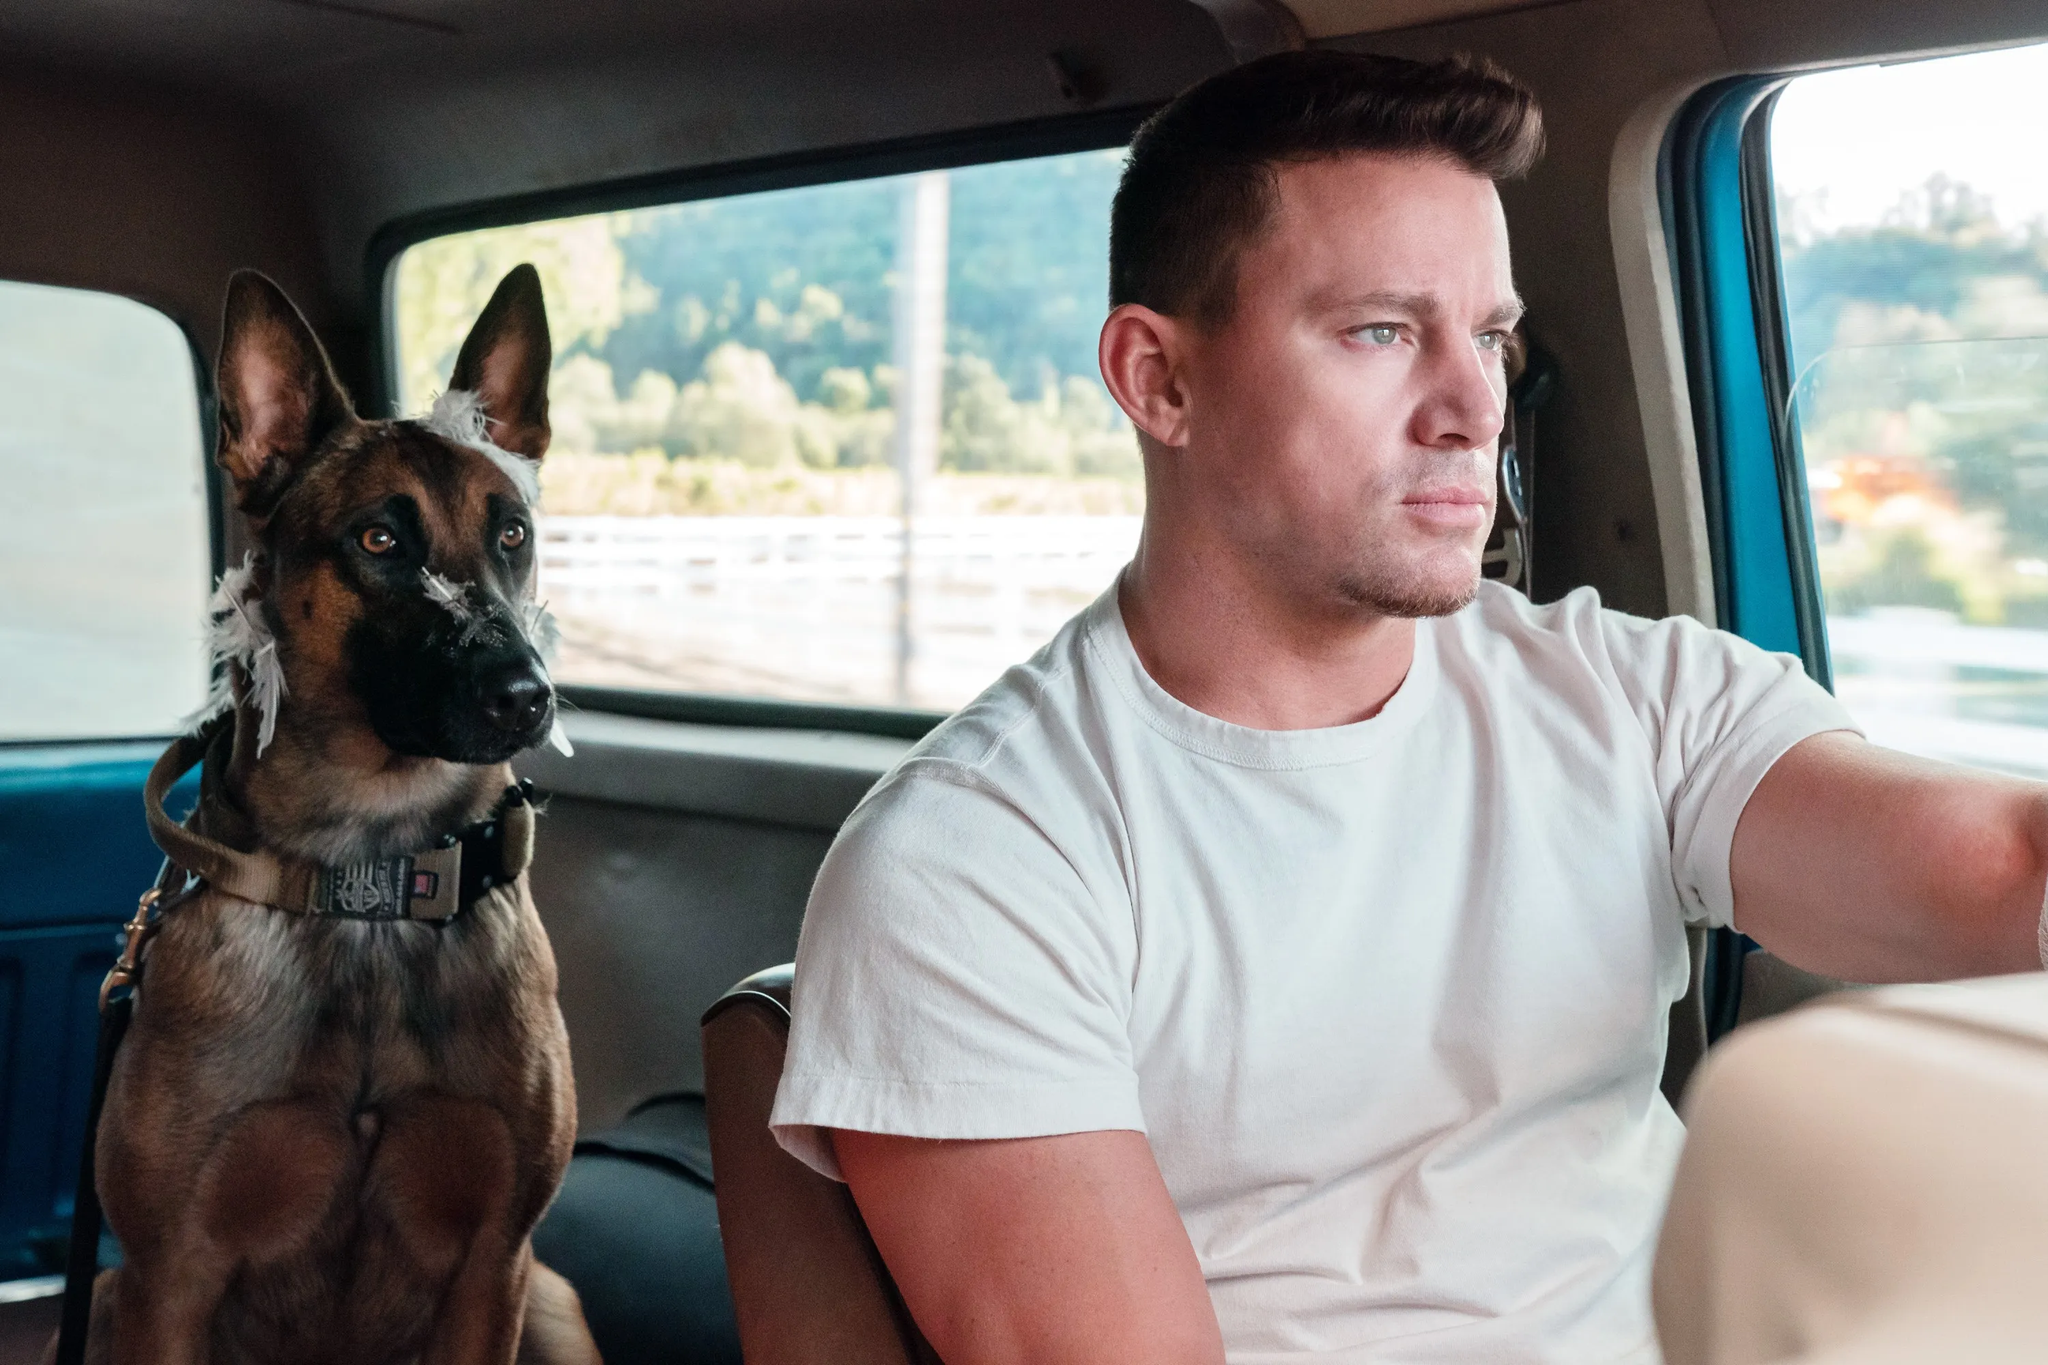What kind of bond do you think exists between the man and the dog in this image? The image suggests a strong bond of trust and companionship. The dog is sitting calmly by the man, which indicates a level of comfort and familiarity with the person. The way the man is devoted to driving while ensuring the dog is seated safely implies responsibility and care. Their shared comfort in this small space reflects a close and trusting relationship. 